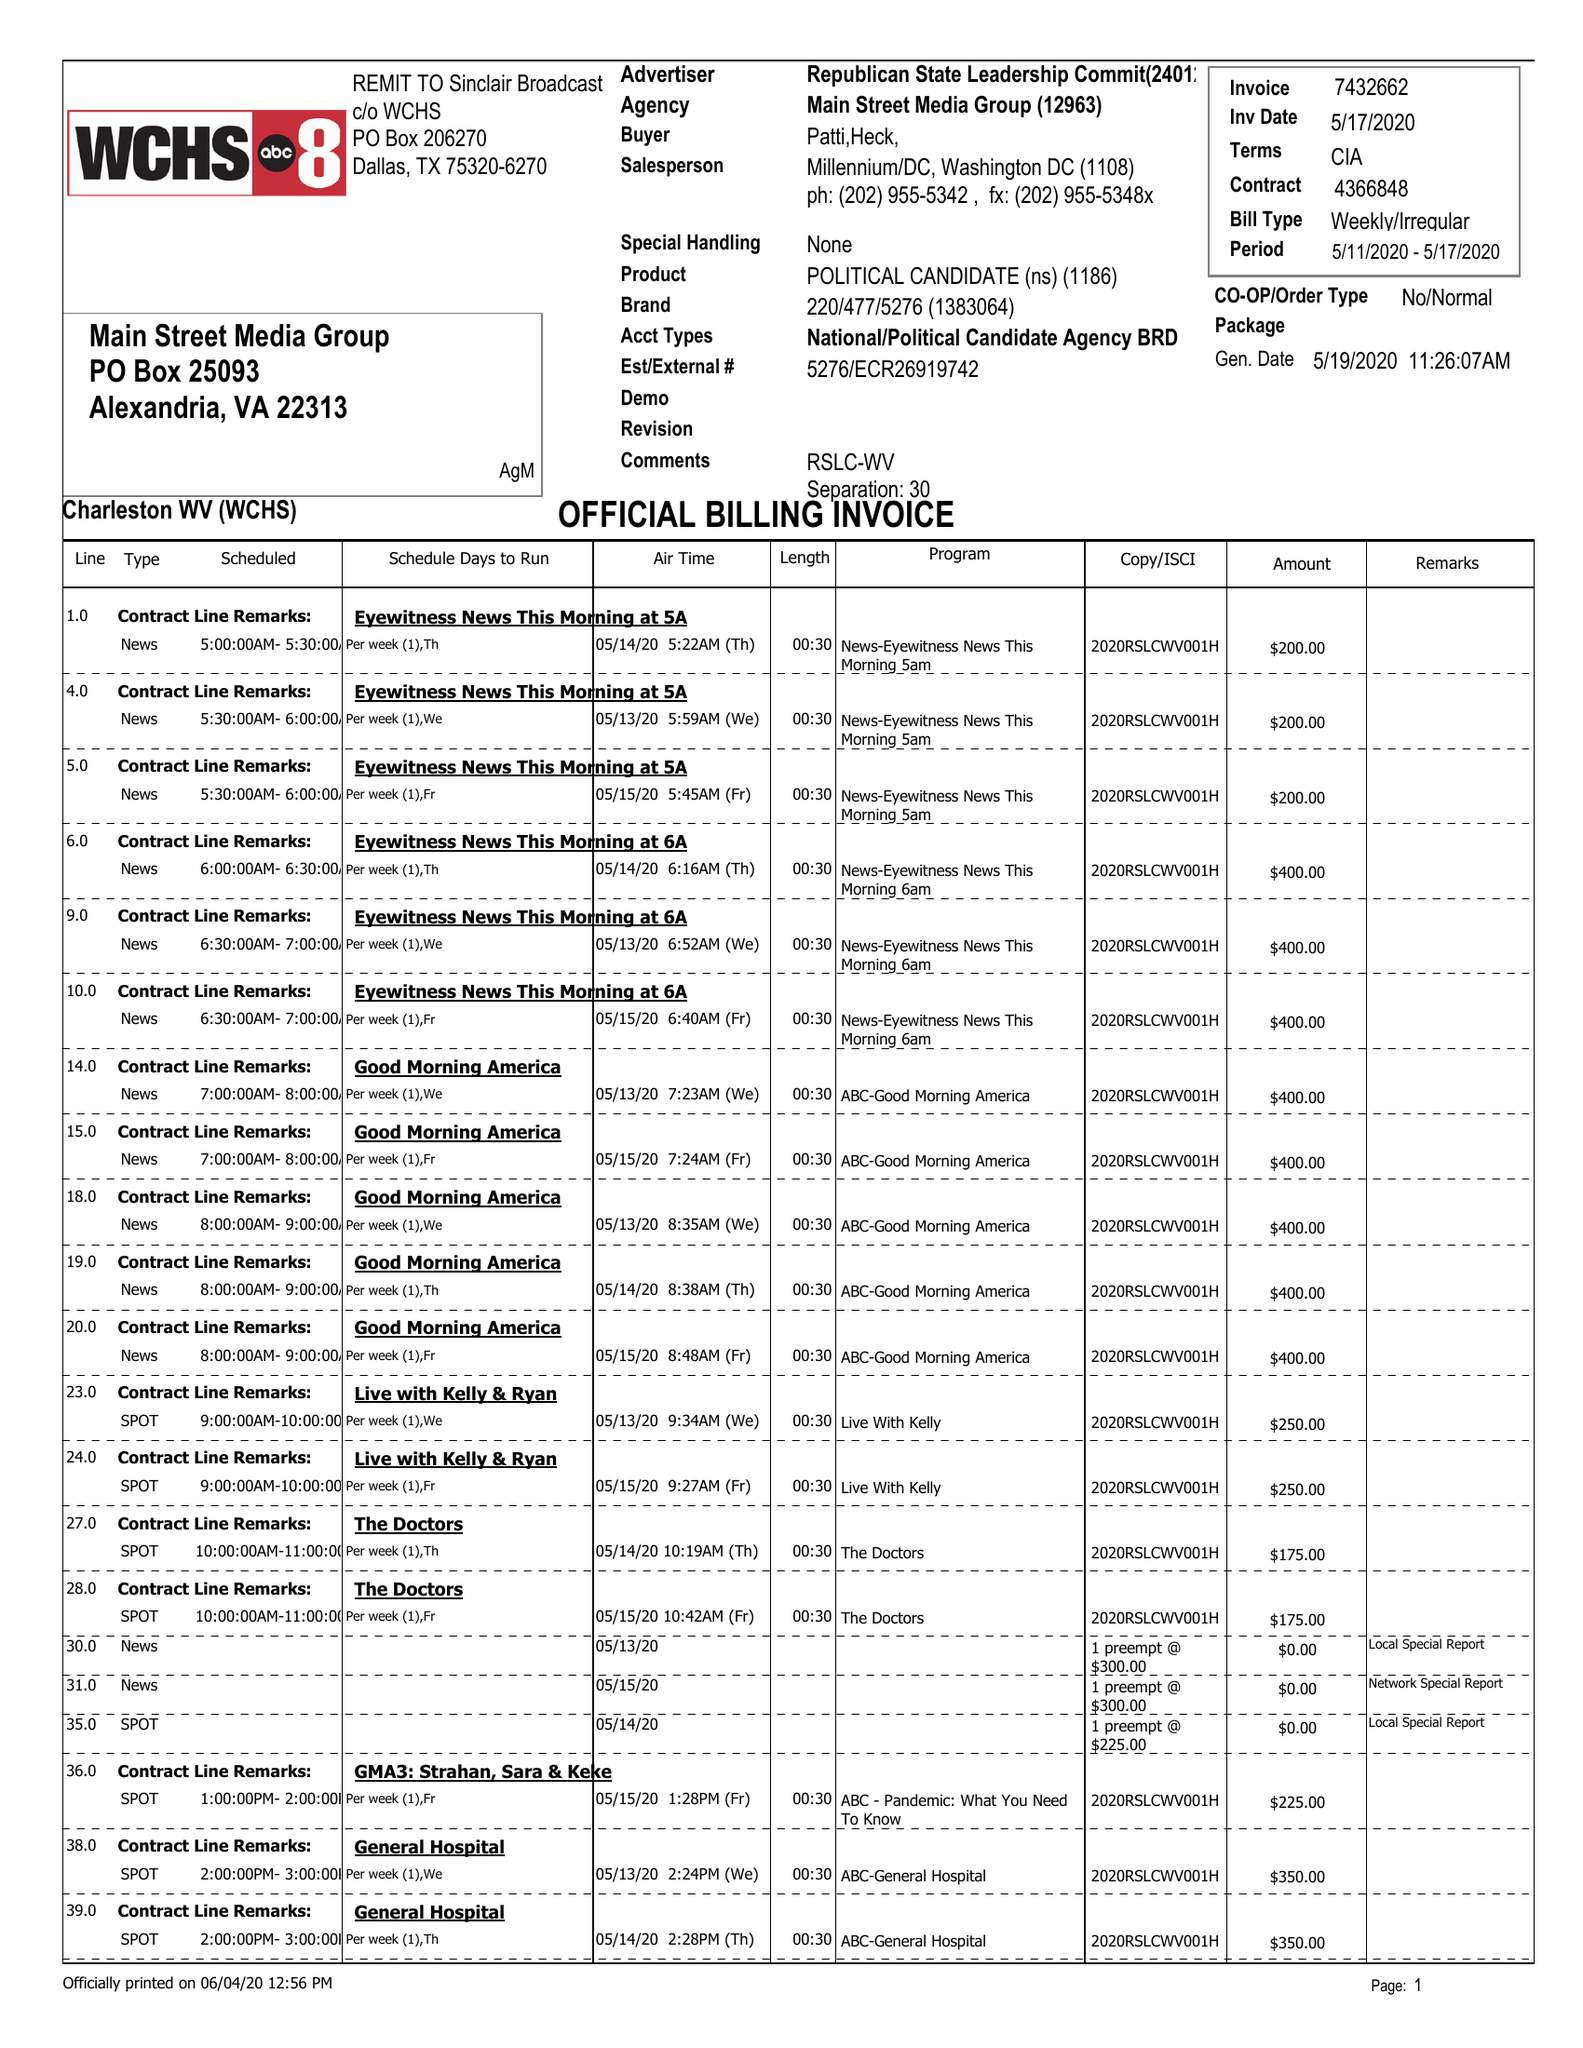What is the value for the contract_num?
Answer the question using a single word or phrase. 4366848 